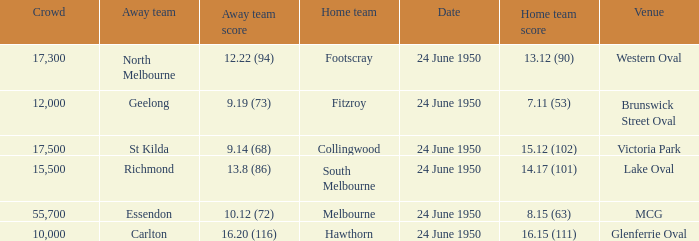Who was the domestic team for the game where north melbourne was the guest team and the attendance was more than 12,000? Footscray. 